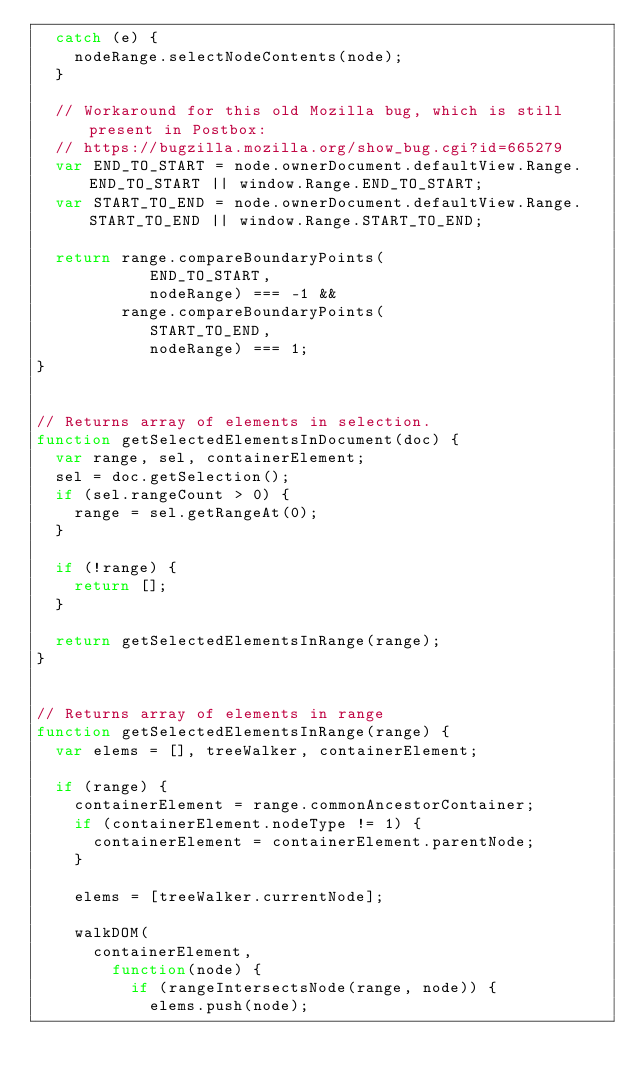Convert code to text. <code><loc_0><loc_0><loc_500><loc_500><_JavaScript_>  catch (e) {
    nodeRange.selectNodeContents(node);
  }

  // Workaround for this old Mozilla bug, which is still present in Postbox:
  // https://bugzilla.mozilla.org/show_bug.cgi?id=665279
  var END_TO_START = node.ownerDocument.defaultView.Range.END_TO_START || window.Range.END_TO_START;
  var START_TO_END = node.ownerDocument.defaultView.Range.START_TO_END || window.Range.START_TO_END;

  return range.compareBoundaryPoints(
            END_TO_START,
            nodeRange) === -1 &&
         range.compareBoundaryPoints(
            START_TO_END,
            nodeRange) === 1;
}


// Returns array of elements in selection.
function getSelectedElementsInDocument(doc) {
  var range, sel, containerElement;
  sel = doc.getSelection();
  if (sel.rangeCount > 0) {
    range = sel.getRangeAt(0);
  }

  if (!range) {
    return [];
  }

  return getSelectedElementsInRange(range);
}


// Returns array of elements in range
function getSelectedElementsInRange(range) {
  var elems = [], treeWalker, containerElement;

  if (range) {
    containerElement = range.commonAncestorContainer;
    if (containerElement.nodeType != 1) {
      containerElement = containerElement.parentNode;
    }

    elems = [treeWalker.currentNode];

    walkDOM(
      containerElement,
        function(node) {
          if (rangeIntersectsNode(range, node)) {
            elems.push(node);</code> 